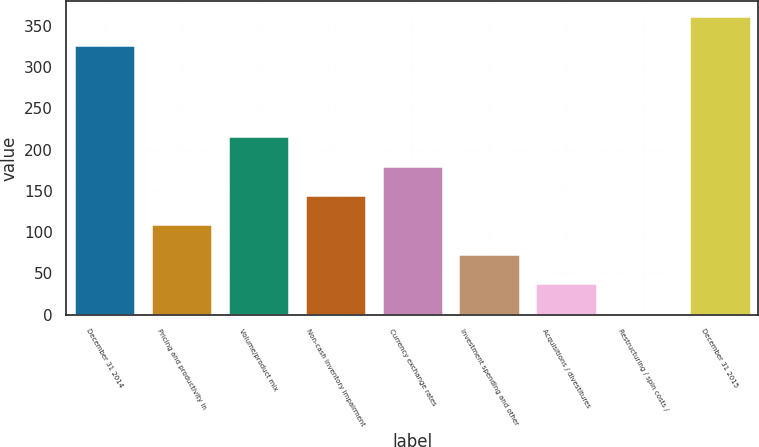<chart> <loc_0><loc_0><loc_500><loc_500><bar_chart><fcel>December 31 2014<fcel>Pricing and productivity in<fcel>Volume/product mix<fcel>Non-cash inventory impairment<fcel>Currency exchange rates<fcel>Investment spending and other<fcel>Acquisitions / divestitures<fcel>Restructuring / spin costs /<fcel>December 31 2015<nl><fcel>326.3<fcel>109.33<fcel>216.16<fcel>144.94<fcel>180.55<fcel>73.72<fcel>38.11<fcel>2.5<fcel>361.91<nl></chart> 